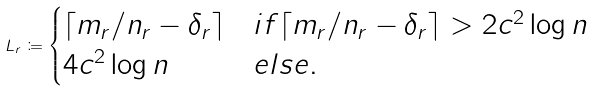<formula> <loc_0><loc_0><loc_500><loc_500>L _ { r } \coloneqq \begin{cases} \lceil m _ { r } / n _ { r } - \delta _ { r } \rceil & i f \lceil m _ { r } / n _ { r } - \delta _ { r } \rceil > 2 c ^ { 2 } \log n \\ 4 c ^ { 2 } \log n & e l s e . \end{cases}</formula> 